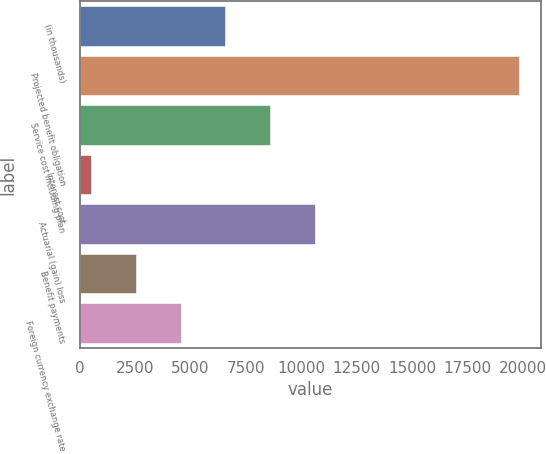Convert chart. <chart><loc_0><loc_0><loc_500><loc_500><bar_chart><fcel>(in thousands)<fcel>Projected benefit obligation<fcel>Service cost including plan<fcel>Interest cost<fcel>Actuarial (gain) loss<fcel>Benefit payments<fcel>Foreign currency exchange rate<nl><fcel>6569.3<fcel>19825<fcel>8592.4<fcel>500<fcel>10615.5<fcel>2523.1<fcel>4546.2<nl></chart> 